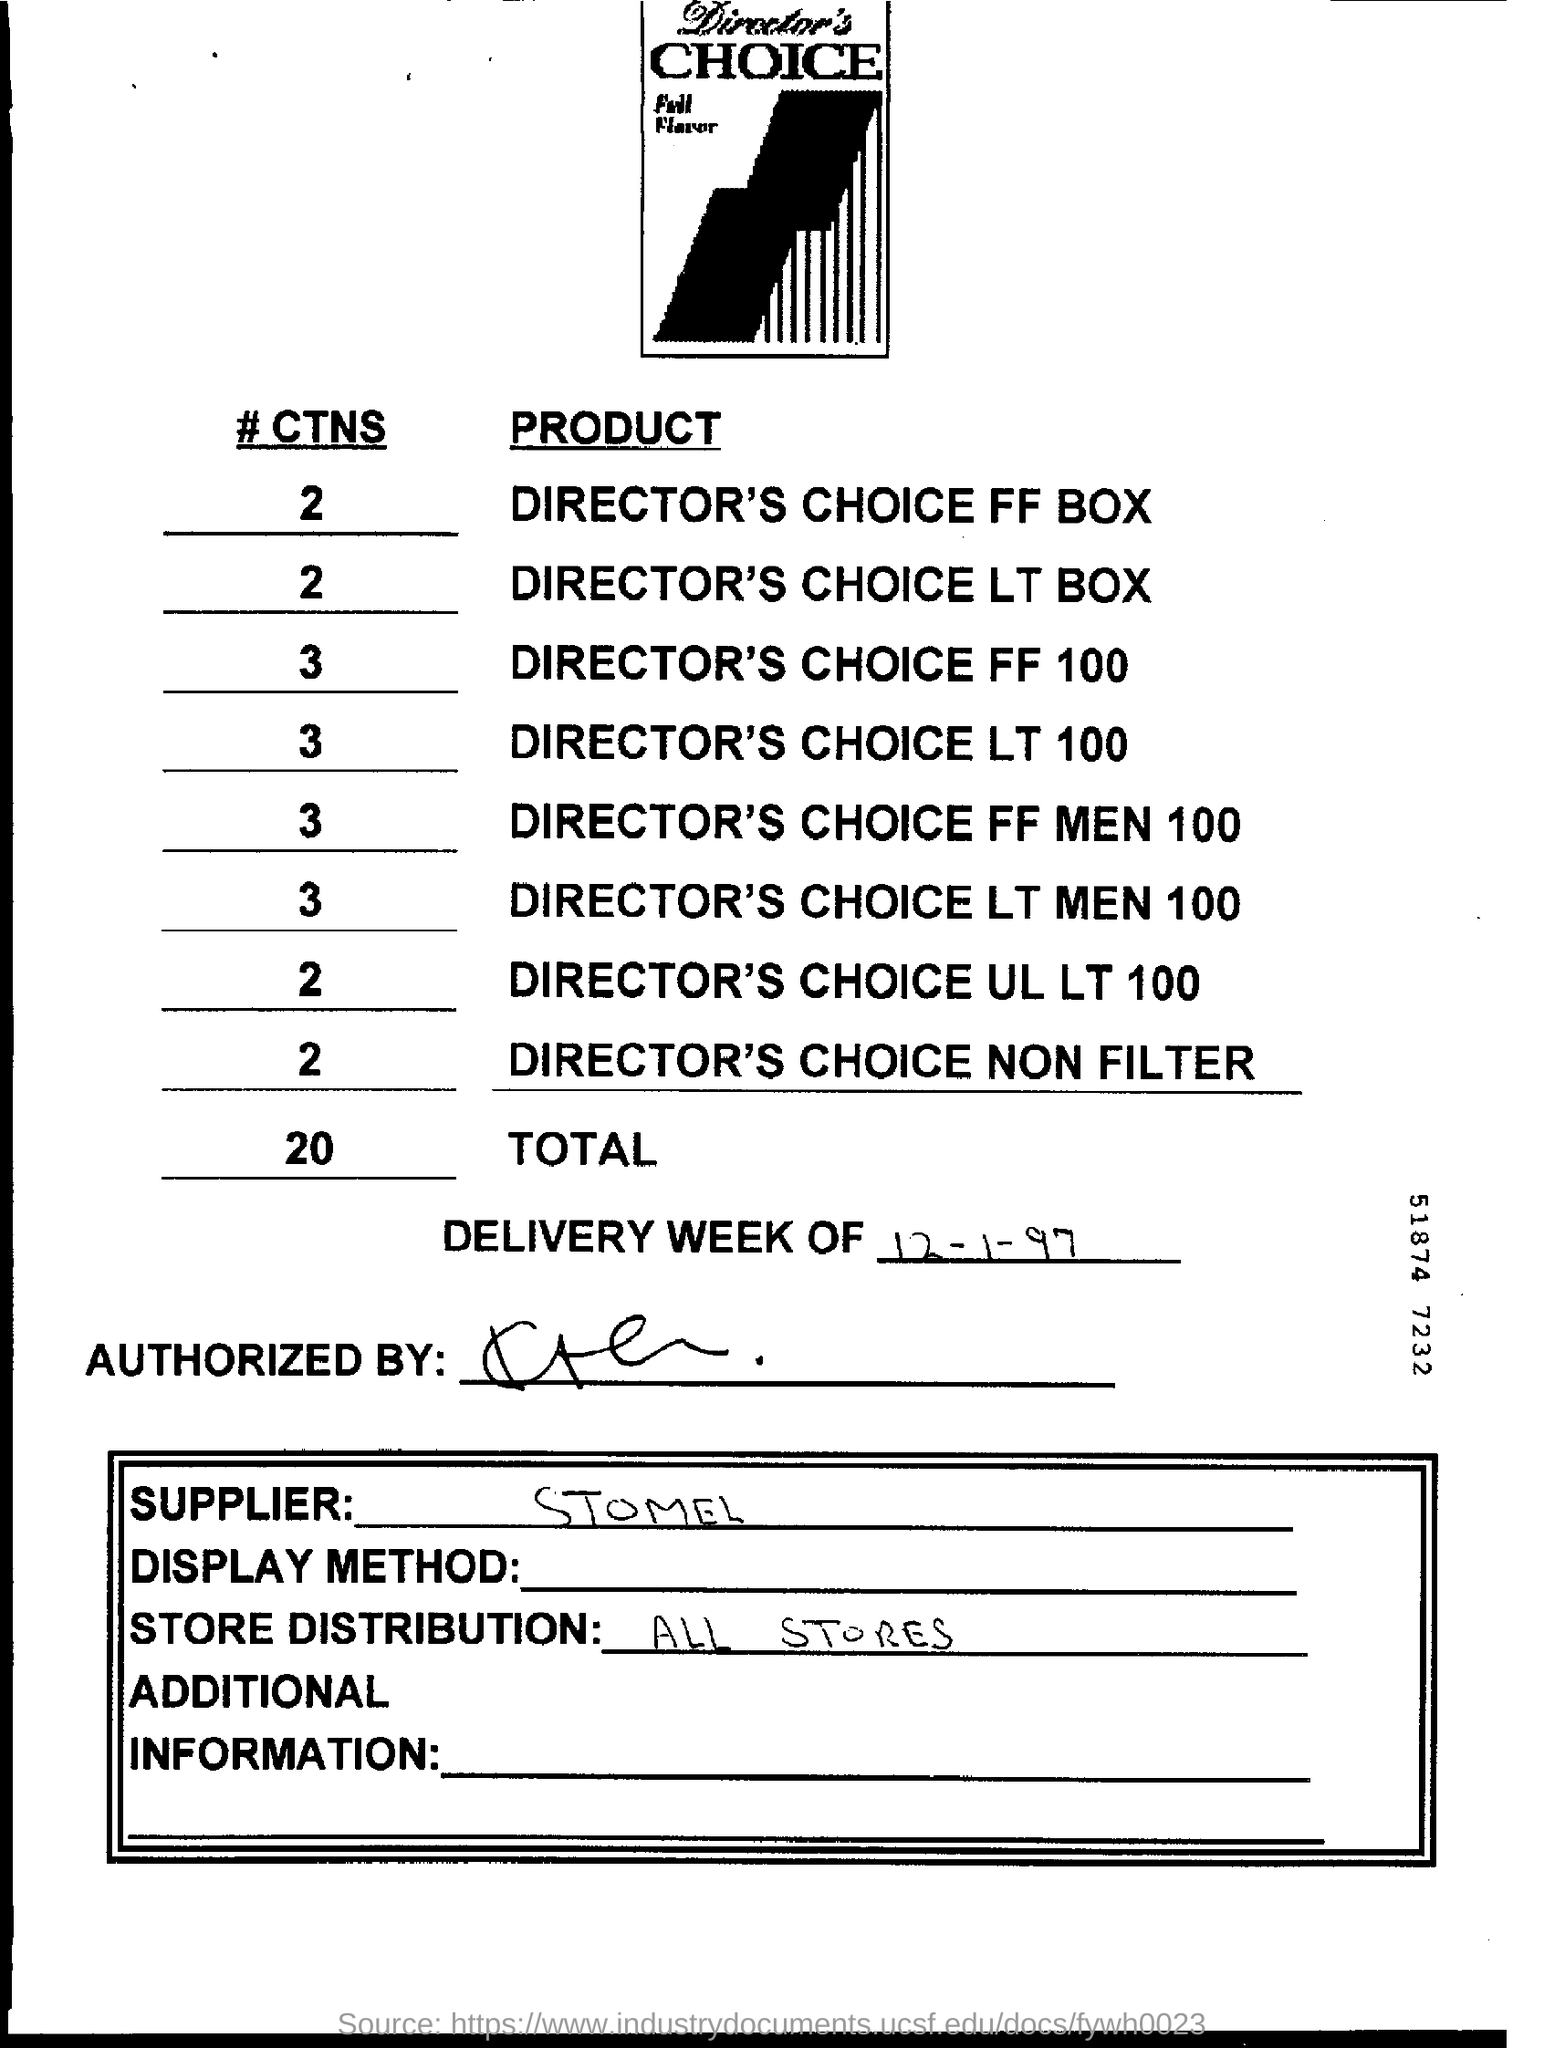What is #CTN total?
Offer a very short reply. 20. What is mentioned in store distribution?
Keep it short and to the point. All Stores. 